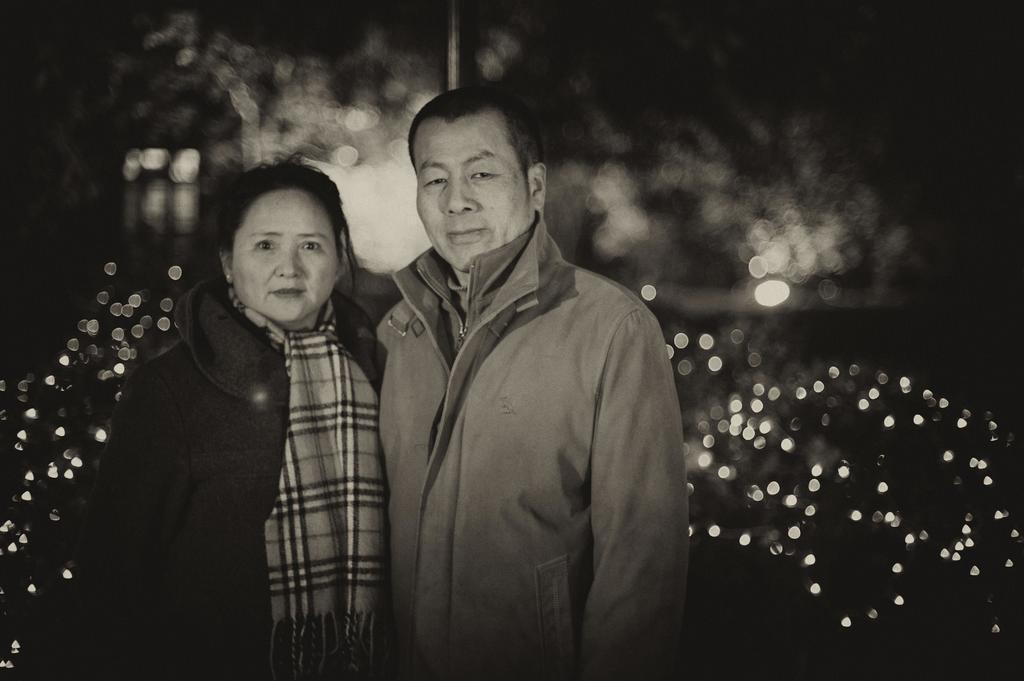Can you describe this image briefly? On the left side, there is a woman in a jacket, smiling and standing. Beside her, there is a person in a jacket, smiling and standing. In the background, there are lights arranged. And the background is dark in color. 